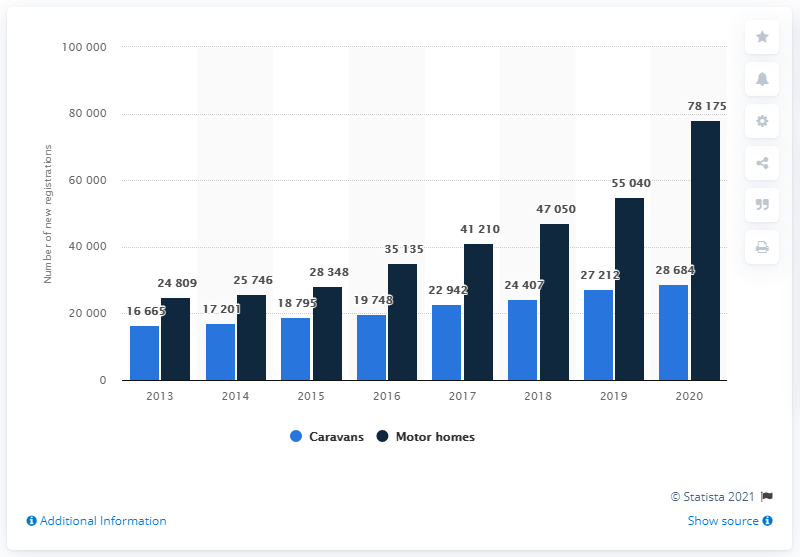Identify some key points in this picture. In recent years, caravans have experienced a minimum increase in price. 